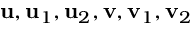Convert formula to latex. <formula><loc_0><loc_0><loc_500><loc_500>u , u _ { 1 } , u _ { 2 } , v , v _ { 1 } , v _ { 2 }</formula> 